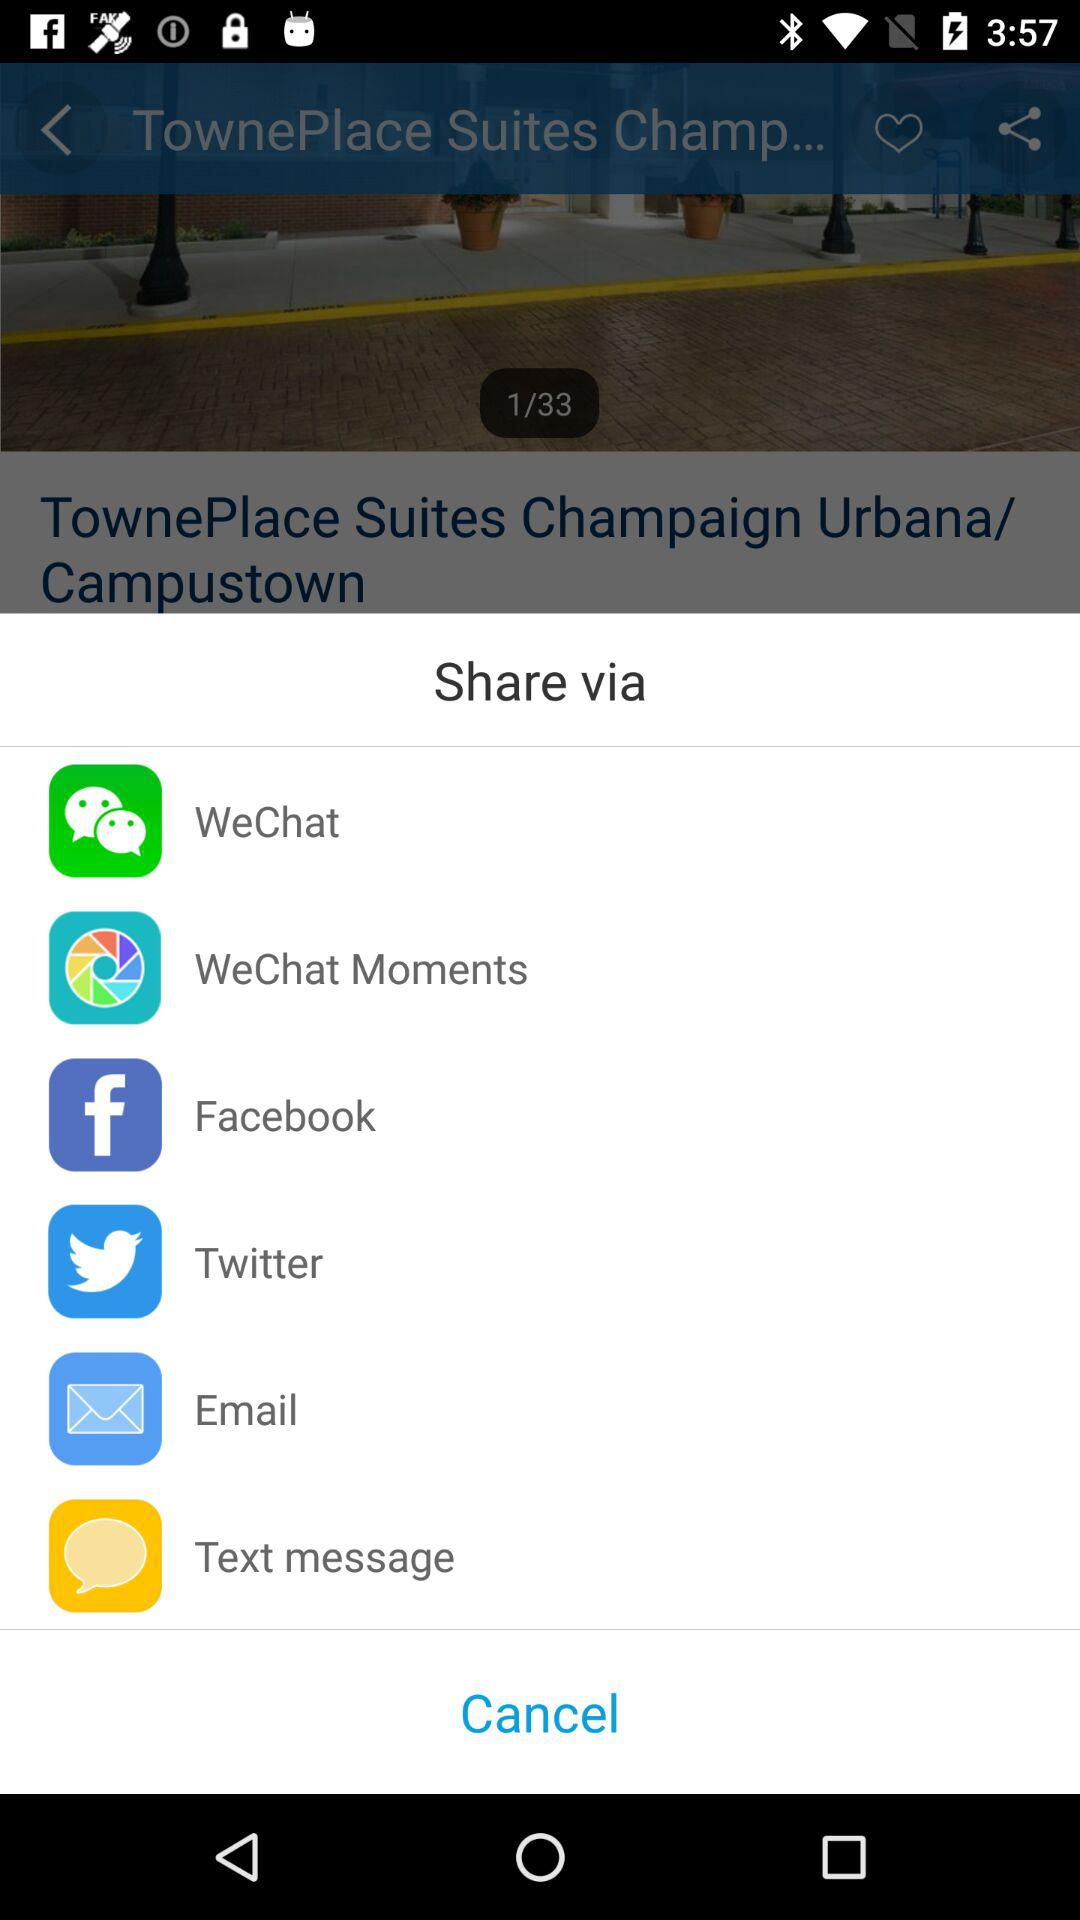What are sharing options? The sharing options are "WeChat", "WeChat Moments", "Facebook", "Twitter", "Email" and "Text message". 